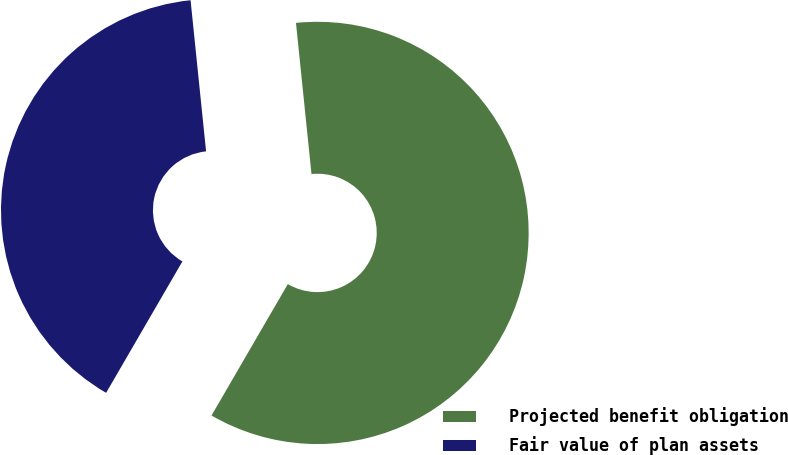<chart> <loc_0><loc_0><loc_500><loc_500><pie_chart><fcel>Projected benefit obligation<fcel>Fair value of plan assets<nl><fcel>60.0%<fcel>40.0%<nl></chart> 